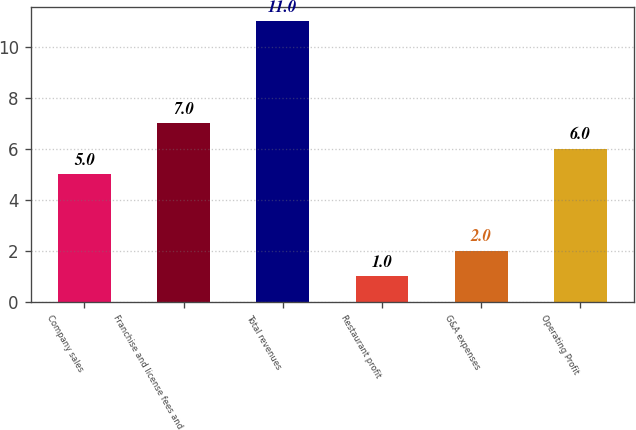Convert chart to OTSL. <chart><loc_0><loc_0><loc_500><loc_500><bar_chart><fcel>Company sales<fcel>Franchise and license fees and<fcel>Total revenues<fcel>Restaurant profit<fcel>G&A expenses<fcel>Operating Profit<nl><fcel>5<fcel>7<fcel>11<fcel>1<fcel>2<fcel>6<nl></chart> 